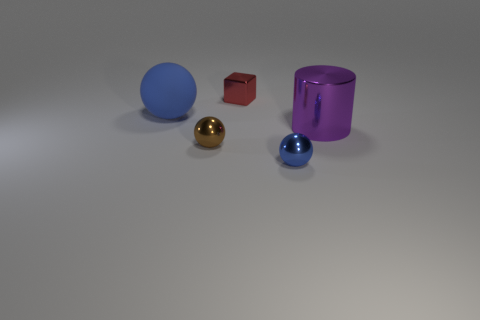There is a brown thing that is the same size as the red shiny object; what is it made of? The brown object, which is similar in size to the red cube, appears to be made of wood, judging by its color and texture. 